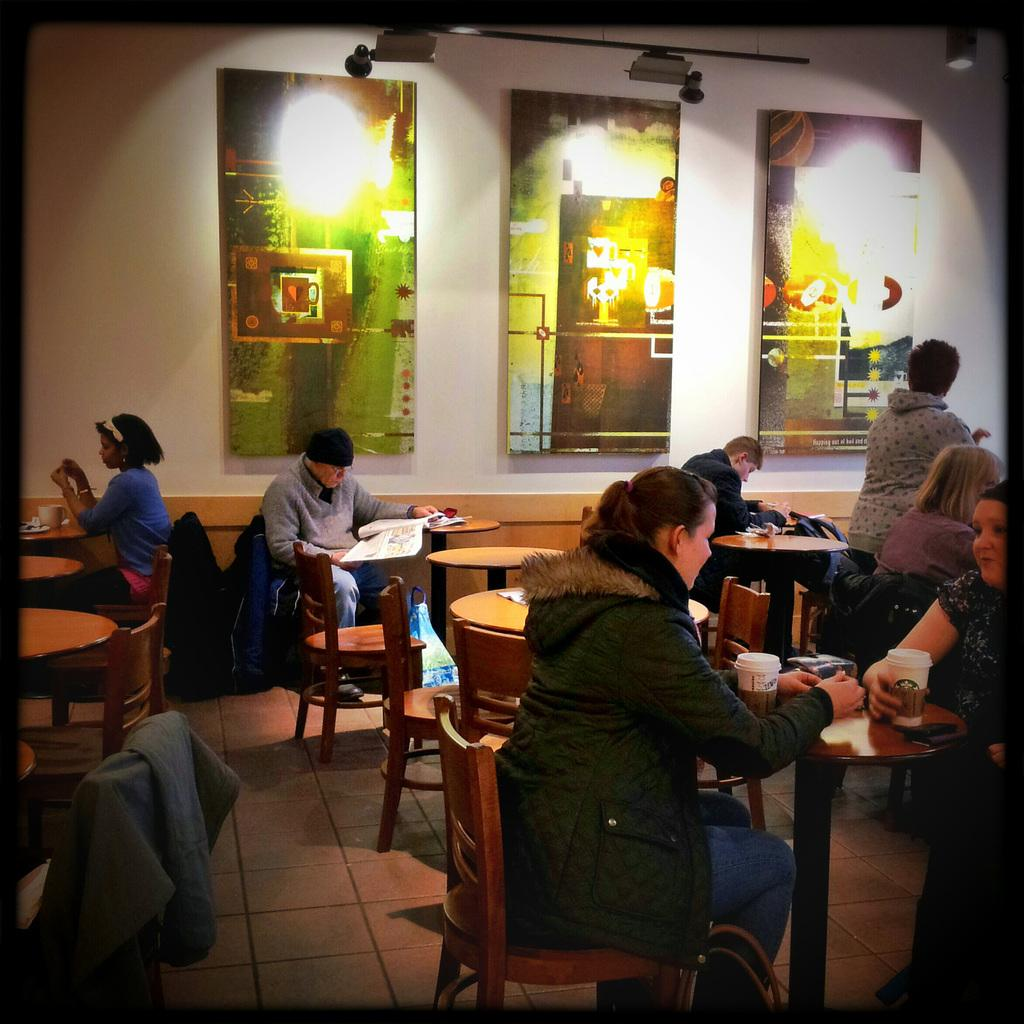What are the people in the image doing? The people in the image are sitting on chairs. What else can be seen in the image besides the people? There are tables in the image. What decorative elements are present on the walls in the image? There are paintings on the wall in the image. What type of straw is being used by the woman in the image? There is no woman or straw present in the image. 